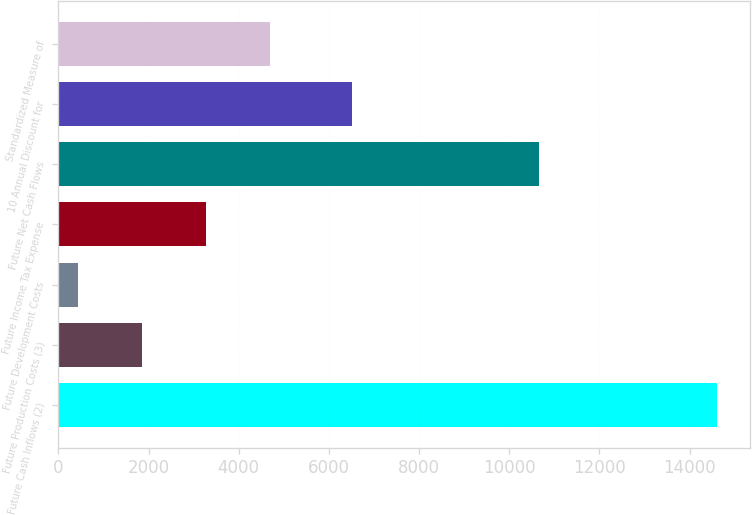Convert chart to OTSL. <chart><loc_0><loc_0><loc_500><loc_500><bar_chart><fcel>Future Cash Inflows (2)<fcel>Future Production Costs (3)<fcel>Future Development Costs<fcel>Future Income Tax Expense<fcel>Future Net Cash Flows<fcel>10 Annual Discount for<fcel>Standardized Measure of<nl><fcel>14608<fcel>1856.8<fcel>440<fcel>3273.6<fcel>10658<fcel>6523<fcel>4690.4<nl></chart> 